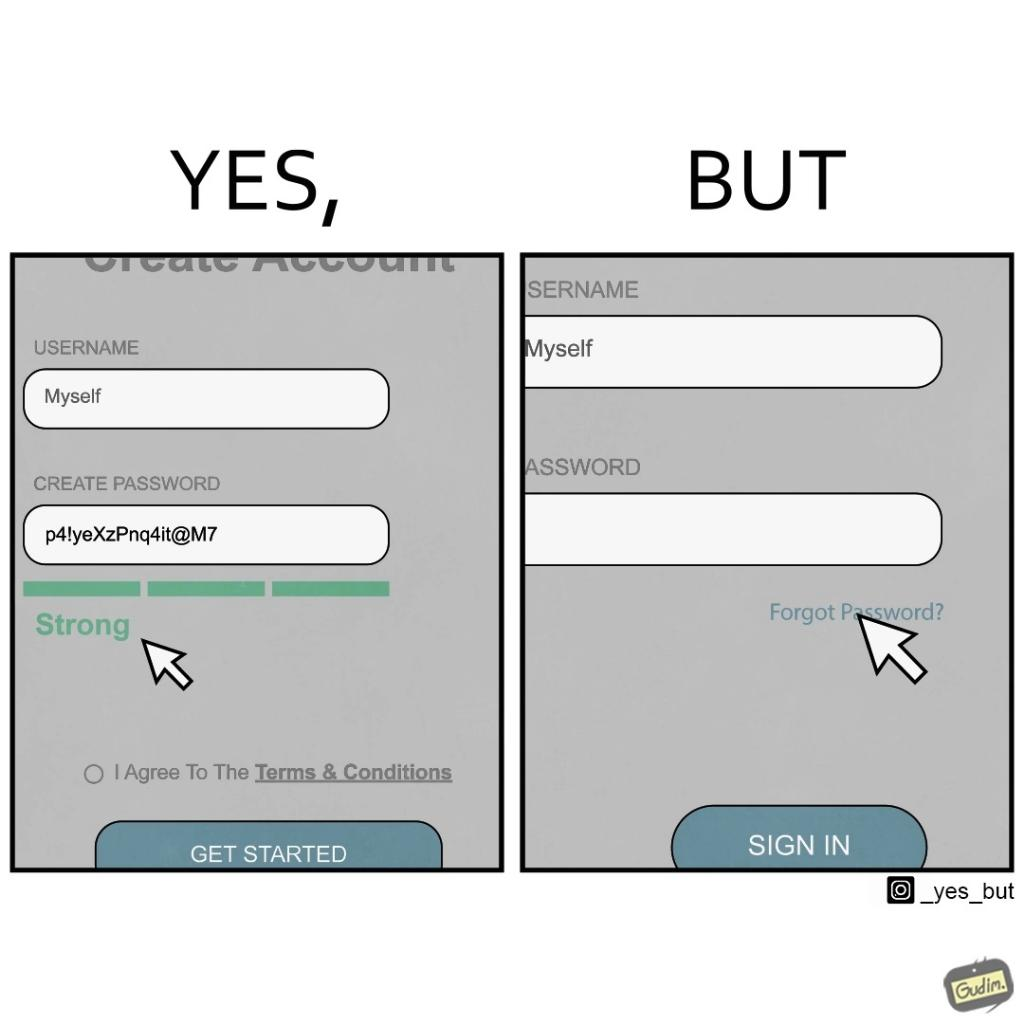Describe the satirical element in this image. The image is ironic, because people set such a strong passwords for their accounts that they even forget the password and need to reset them 